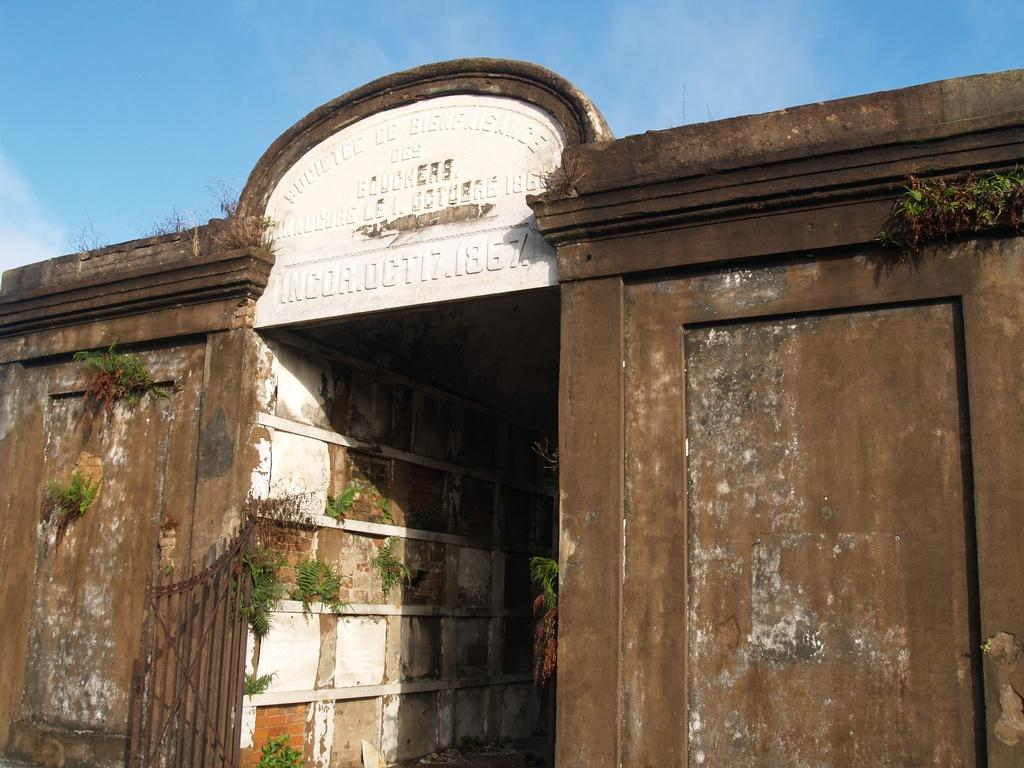What type of structure is present in the image? There is a building in the image. What is the entrance to the building like? There is a gate in the image. What type of vegetation can be seen in the image? There are plants in the image. What is written in the middle of the image? There is text written in the middle of the image. What can be seen in the background of the image? The sky is clear and visible in the background of the image. What type of weather condition, such as sleet, can be seen falling in the image? There is no indication of any weather condition, such as sleet, in the image. The sky is clear and visible in the background, suggesting good weather. 